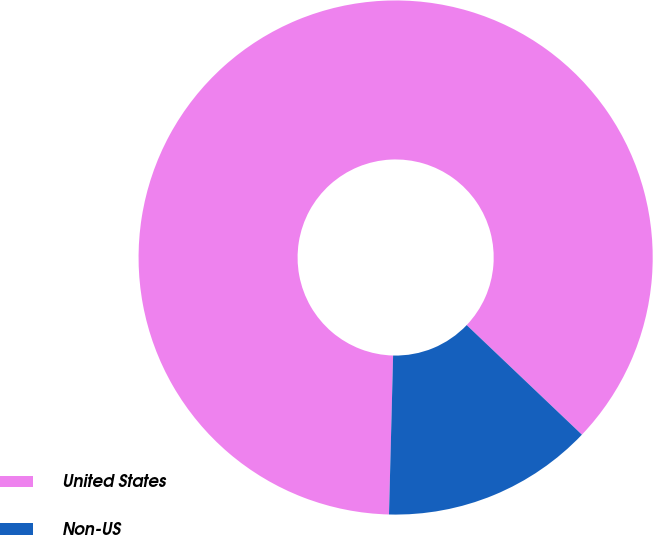Convert chart. <chart><loc_0><loc_0><loc_500><loc_500><pie_chart><fcel>United States<fcel>Non-US<nl><fcel>86.69%<fcel>13.31%<nl></chart> 